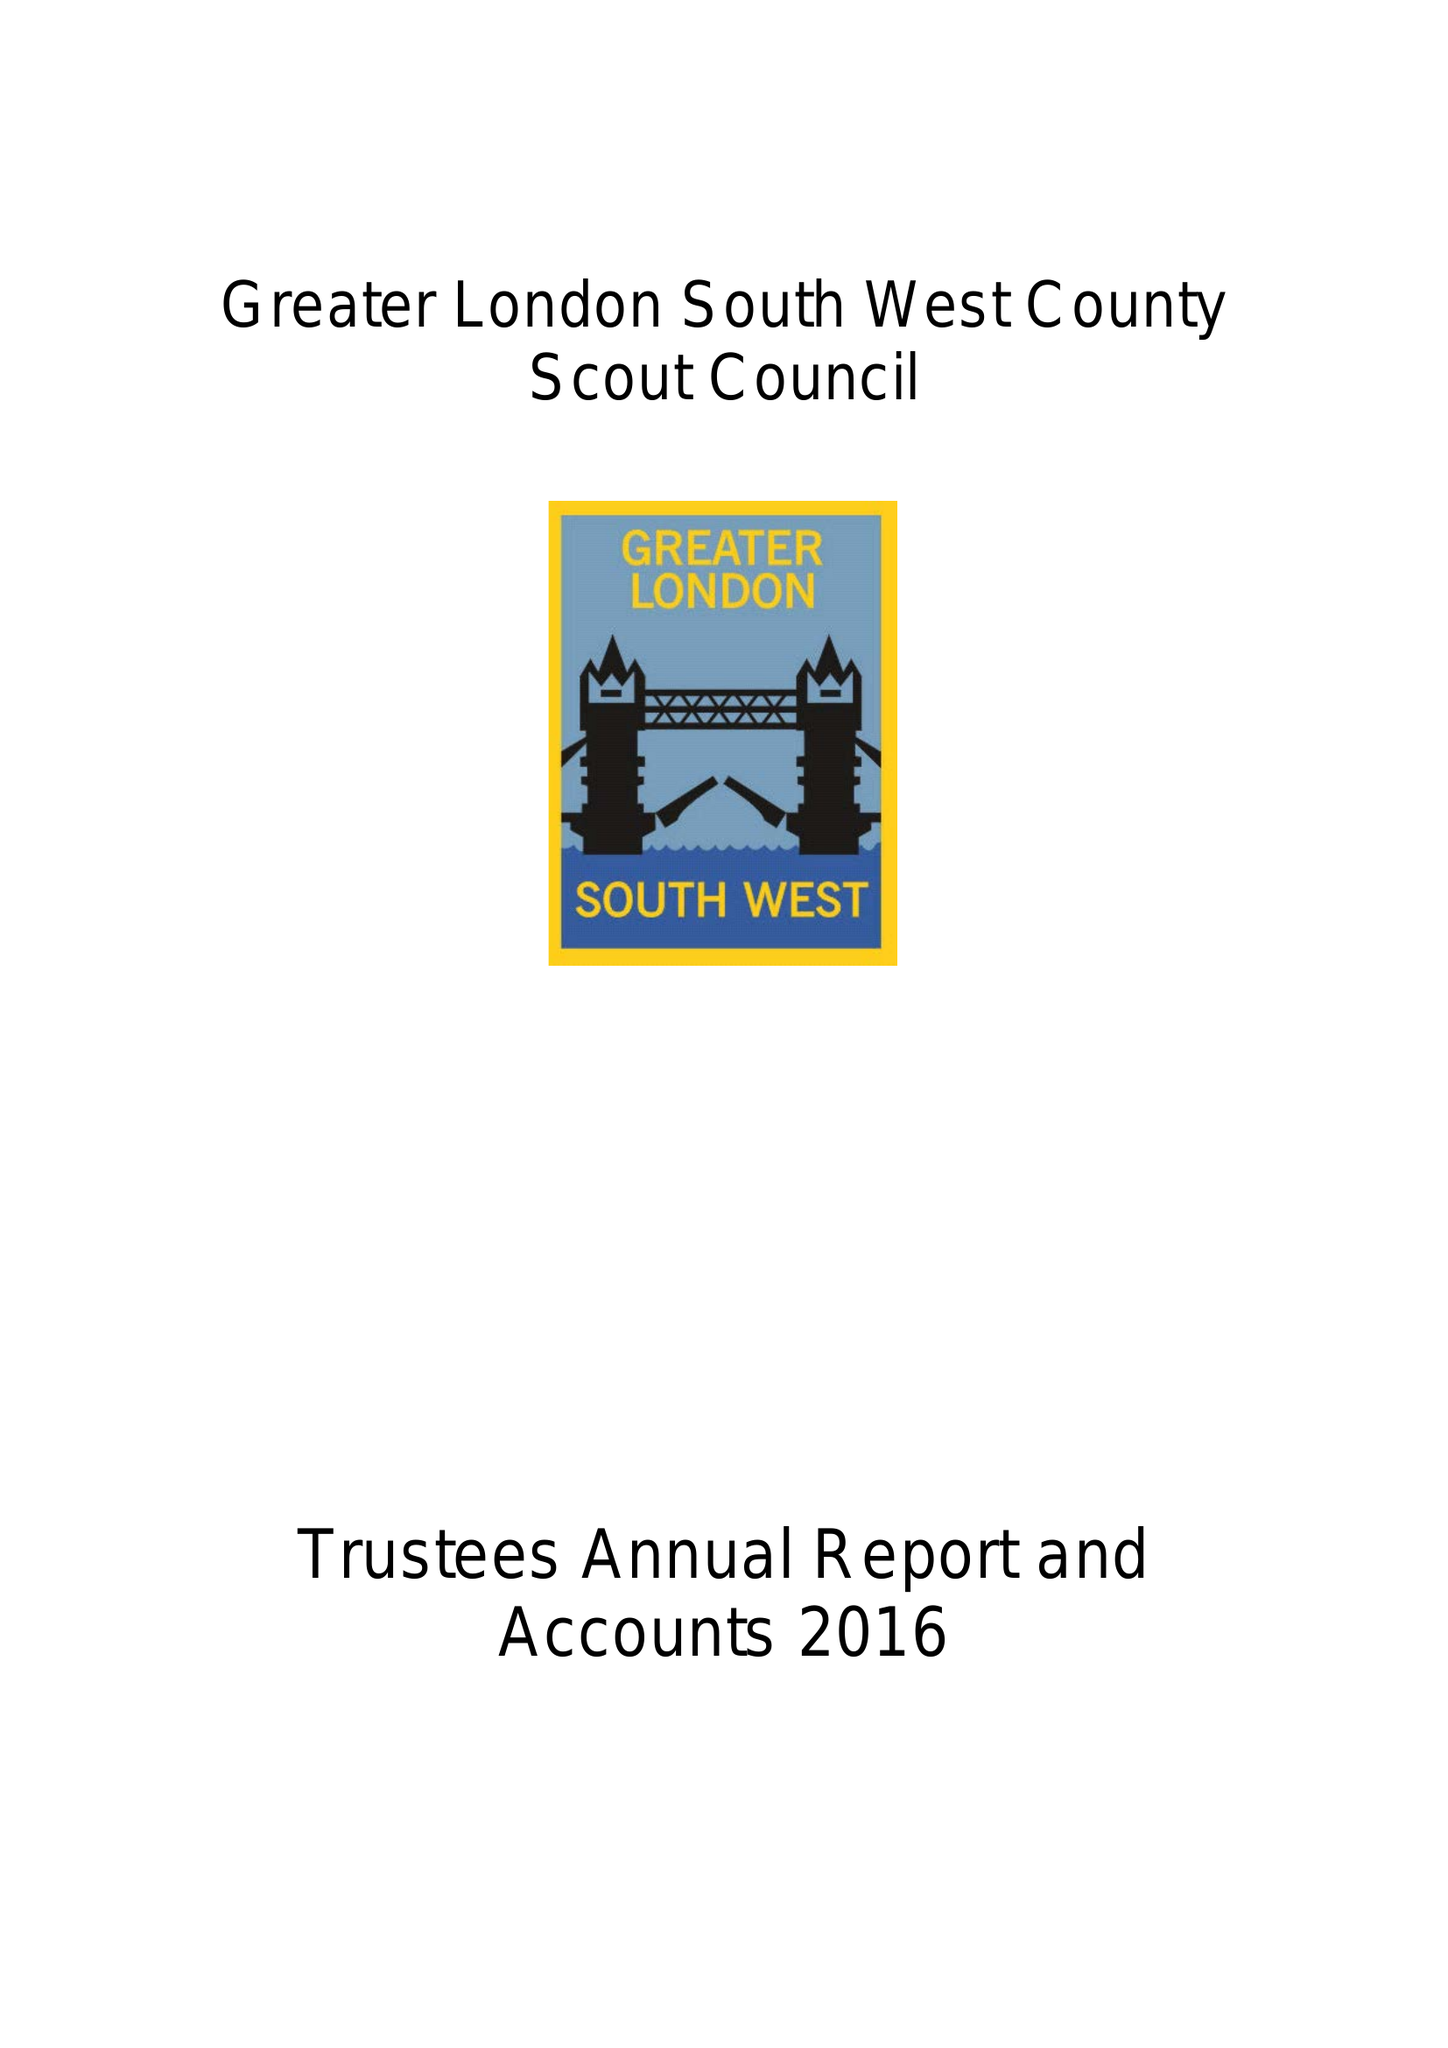What is the value for the address__street_line?
Answer the question using a single word or phrase. 42 THE MOUNT 